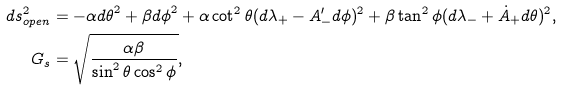<formula> <loc_0><loc_0><loc_500><loc_500>d s ^ { 2 } _ { o p e n } & = - \alpha { d \theta } ^ { 2 } + \beta { d \phi } ^ { 2 } + \alpha \cot ^ { 2 } \theta ( d \lambda _ { + } - A ^ { \prime } _ { - } d { \phi } ) ^ { 2 } + \beta \tan ^ { 2 } { \phi } ( d \lambda _ { - } + \dot { A } _ { + } d \theta ) ^ { 2 } , \\ G _ { s } & = \sqrt { \frac { \alpha \beta } { \sin ^ { 2 } \theta \cos ^ { 2 } { \phi } } } ,</formula> 